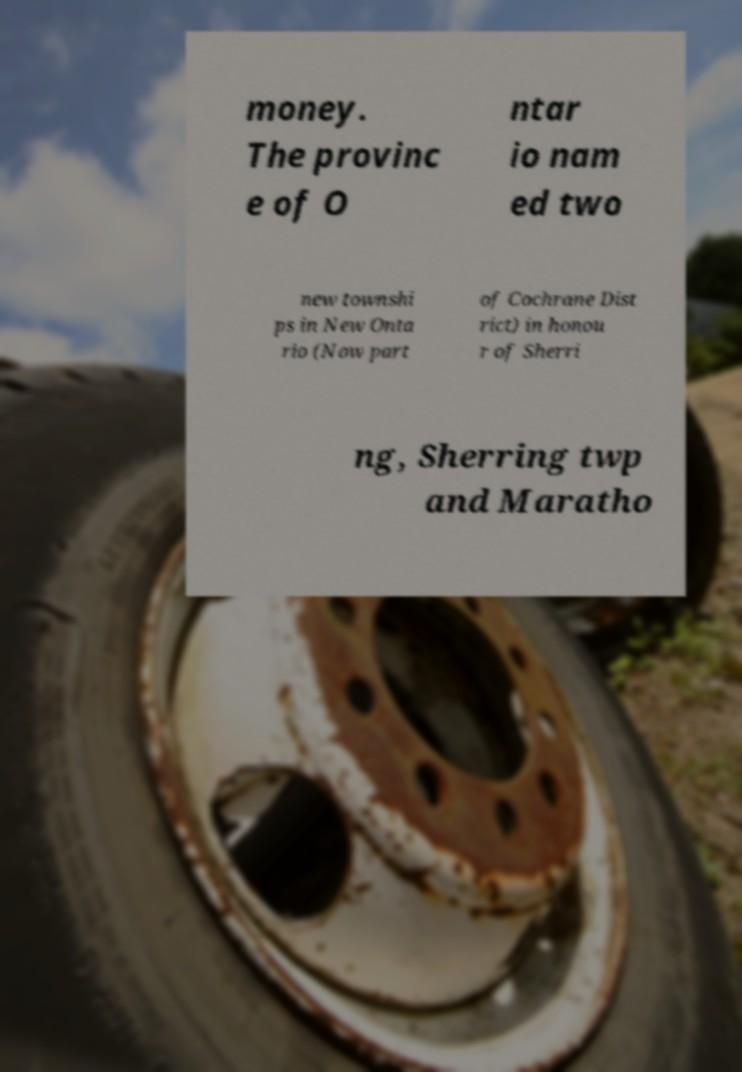Could you extract and type out the text from this image? money. The provinc e of O ntar io nam ed two new townshi ps in New Onta rio (Now part of Cochrane Dist rict) in honou r of Sherri ng, Sherring twp and Maratho 